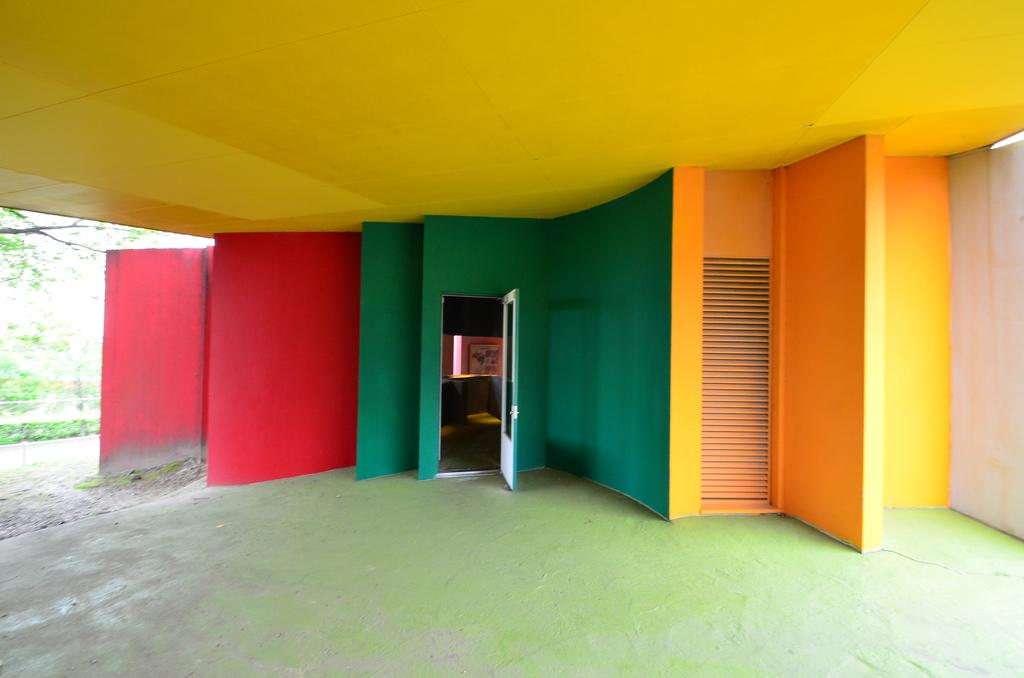What type of structure is visible in the image? There is a door and walls visible in the image. What color is the ceiling in the image? The ceiling is yellow in color. What type of natural element can be seen in the image? There is a tree visible in the image. What other objects can be seen in the image besides the door, walls, and tree? There are other objects present in the image. What type of skirt is hanging on the tree in the image? There is no skirt present in the image; only a tree is visible. What substance is being attracted to the door in the image? There is no substance being attracted to the door in the image; the image does not depict any such phenomenon. 